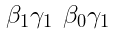<formula> <loc_0><loc_0><loc_500><loc_500>\begin{smallmatrix} \beta _ { 1 } \gamma _ { 1 } & \beta _ { 0 } \gamma _ { 1 } \end{smallmatrix}</formula> 